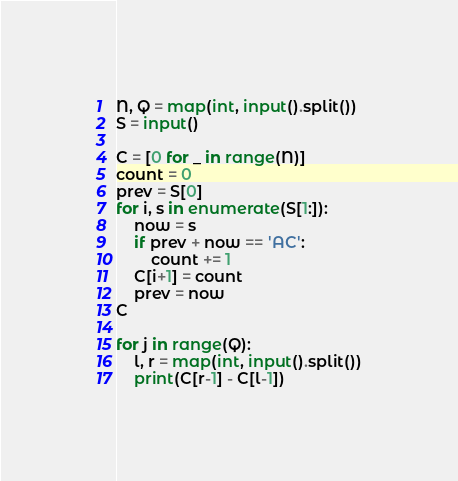Convert code to text. <code><loc_0><loc_0><loc_500><loc_500><_Python_>N, Q = map(int, input().split())
S = input()

C = [0 for _ in range(N)]
count = 0
prev = S[0]
for i, s in enumerate(S[1:]):
    now = s
    if prev + now == 'AC':
        count += 1
    C[i+1] = count
    prev = now
C

for j in range(Q):
    l, r = map(int, input().split())
    print(C[r-1] - C[l-1])</code> 